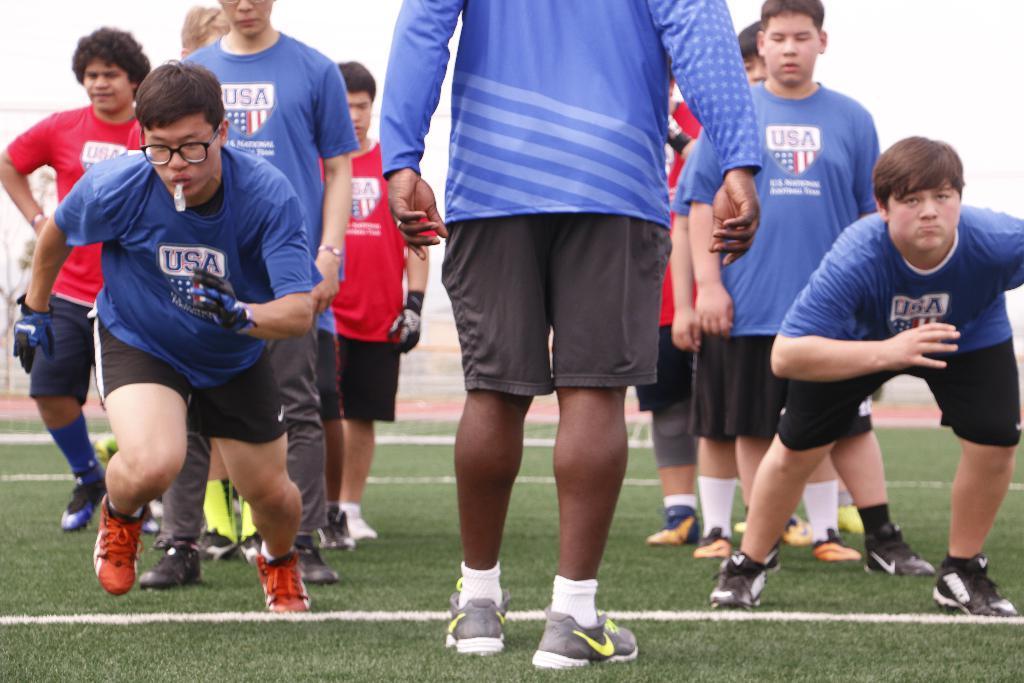Could you give a brief overview of what you see in this image? In this picture I can see group of people. I can see grass, and in the background there is the sky. 